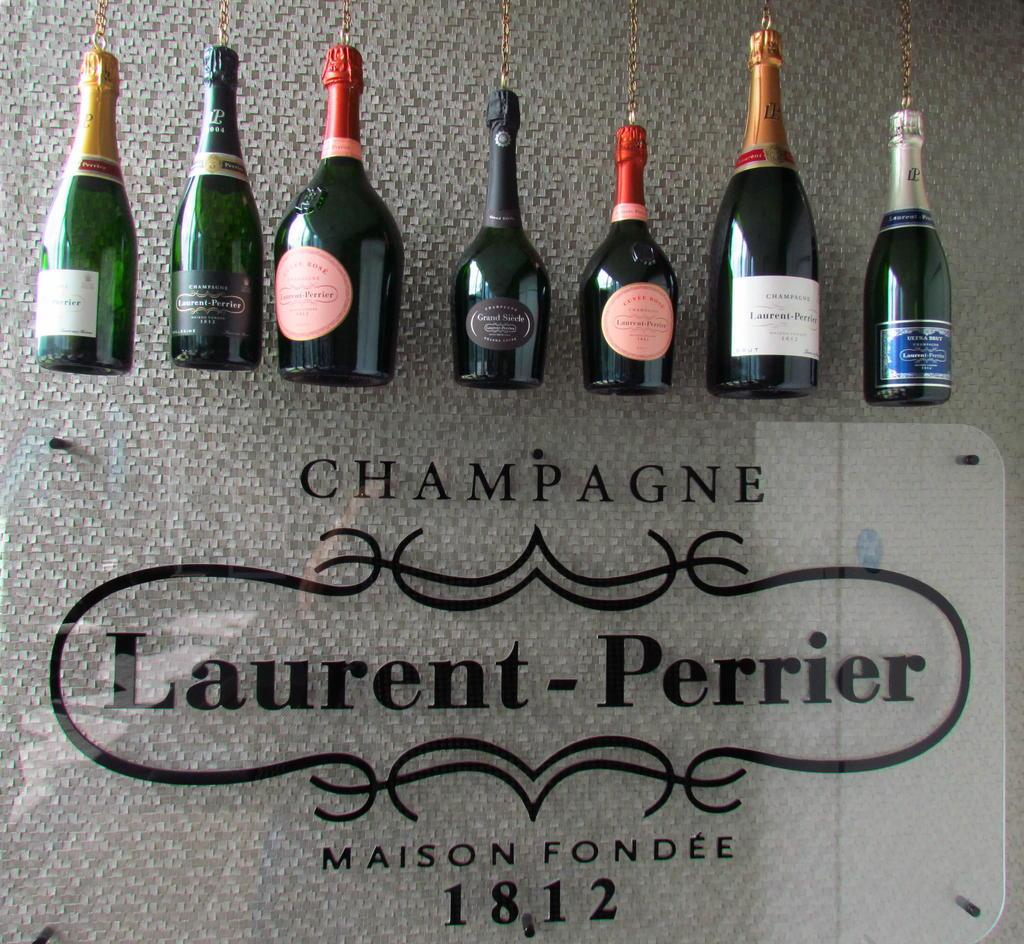<image>
Share a concise interpretation of the image provided. Champagne bottles on top of a sign that has the year 1812 on it. 